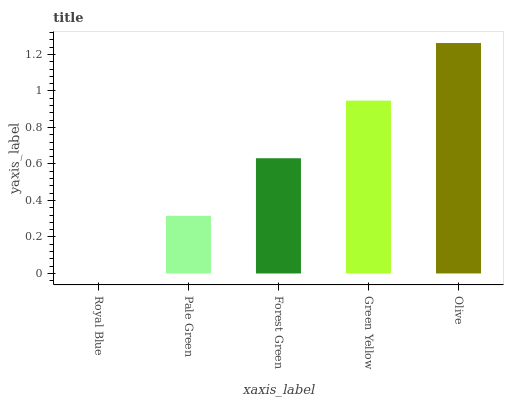Is Pale Green the minimum?
Answer yes or no. No. Is Pale Green the maximum?
Answer yes or no. No. Is Pale Green greater than Royal Blue?
Answer yes or no. Yes. Is Royal Blue less than Pale Green?
Answer yes or no. Yes. Is Royal Blue greater than Pale Green?
Answer yes or no. No. Is Pale Green less than Royal Blue?
Answer yes or no. No. Is Forest Green the high median?
Answer yes or no. Yes. Is Forest Green the low median?
Answer yes or no. Yes. Is Pale Green the high median?
Answer yes or no. No. Is Royal Blue the low median?
Answer yes or no. No. 